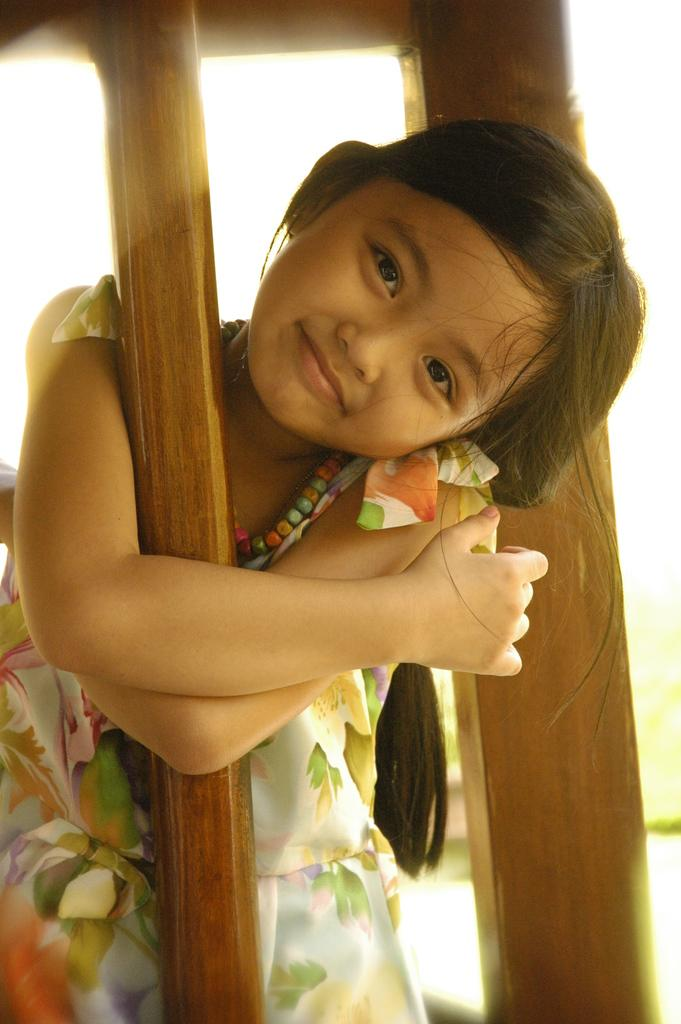Who is the main subject in the image? There is a girl in the image. What is the girl's expression in the image? The girl is smiling in the image. What objects can be seen in the image besides the girl? There are wooden sticks in the image. Can you describe the background of the image? The background of the image is blurred. What type of statement is the girl making in the image? There is no indication in the image that the girl is making a statement, as the focus is on her expression and the presence of wooden sticks. --- 